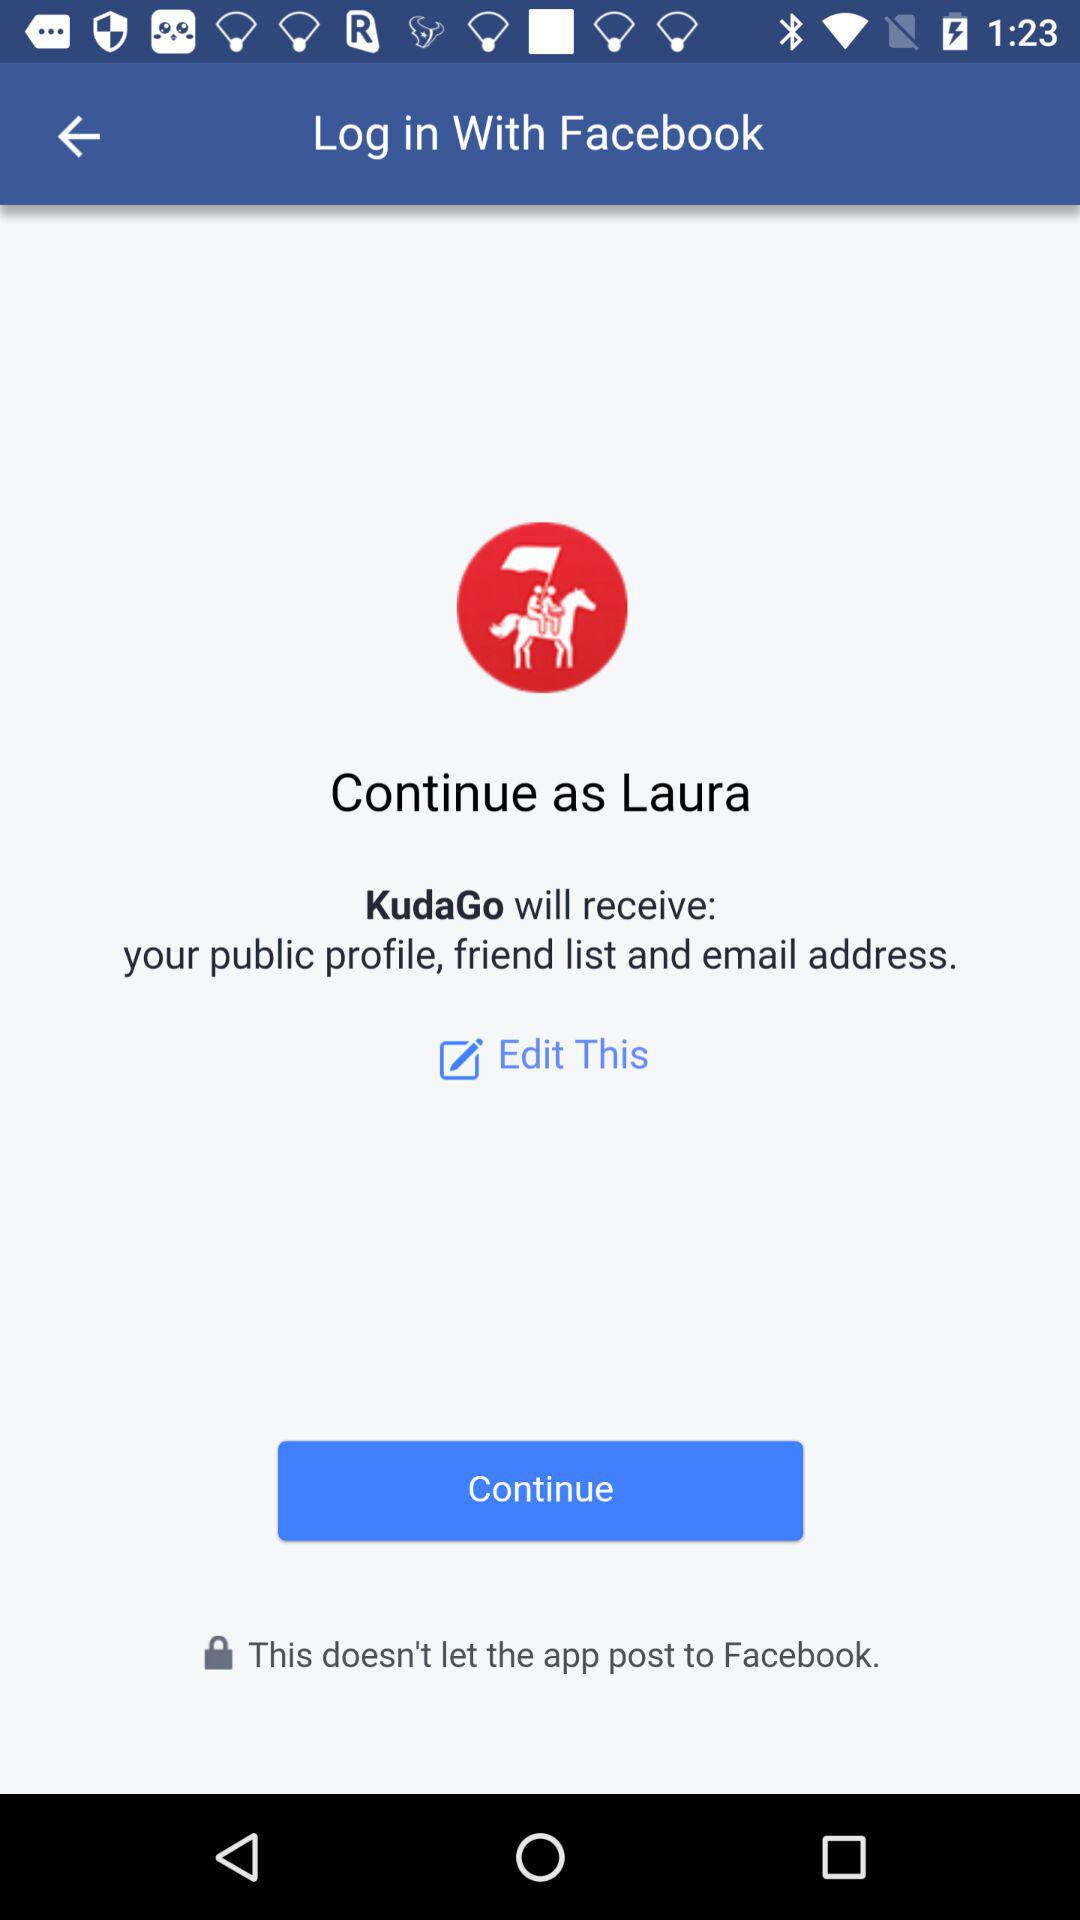Which email address will "KudaGo" have access to?
When the provided information is insufficient, respond with <no answer>. <no answer> 